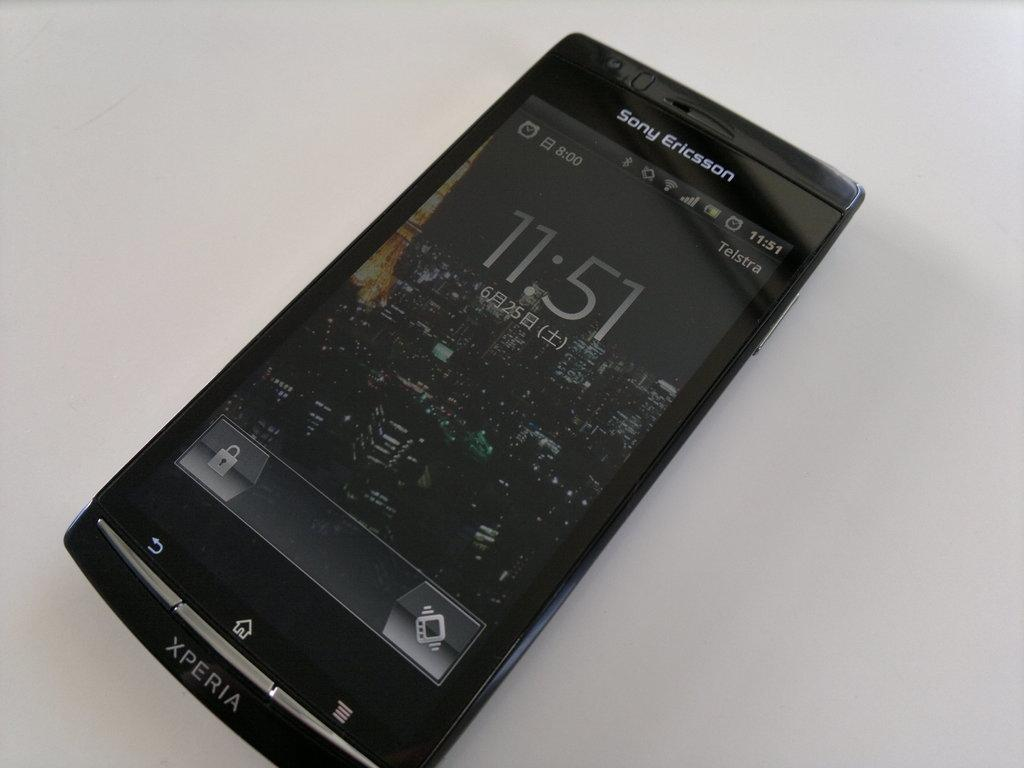<image>
Relay a brief, clear account of the picture shown. A Sony Ericsson Xperia phone turned on and showing 11:51. 